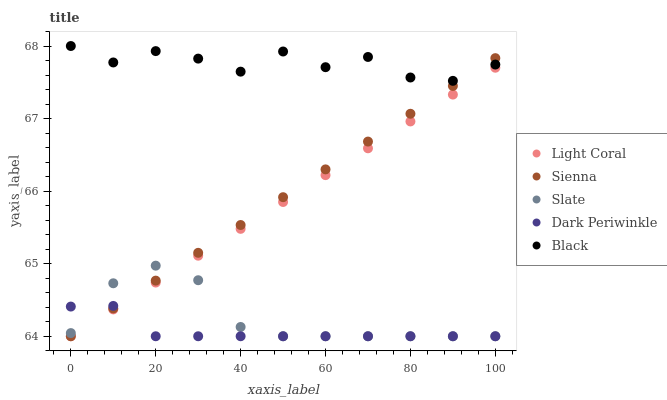Does Dark Periwinkle have the minimum area under the curve?
Answer yes or no. Yes. Does Black have the maximum area under the curve?
Answer yes or no. Yes. Does Sienna have the minimum area under the curve?
Answer yes or no. No. Does Sienna have the maximum area under the curve?
Answer yes or no. No. Is Light Coral the smoothest?
Answer yes or no. Yes. Is Black the roughest?
Answer yes or no. Yes. Is Sienna the smoothest?
Answer yes or no. No. Is Sienna the roughest?
Answer yes or no. No. Does Light Coral have the lowest value?
Answer yes or no. Yes. Does Black have the lowest value?
Answer yes or no. No. Does Black have the highest value?
Answer yes or no. Yes. Does Sienna have the highest value?
Answer yes or no. No. Is Light Coral less than Black?
Answer yes or no. Yes. Is Black greater than Dark Periwinkle?
Answer yes or no. Yes. Does Slate intersect Sienna?
Answer yes or no. Yes. Is Slate less than Sienna?
Answer yes or no. No. Is Slate greater than Sienna?
Answer yes or no. No. Does Light Coral intersect Black?
Answer yes or no. No. 